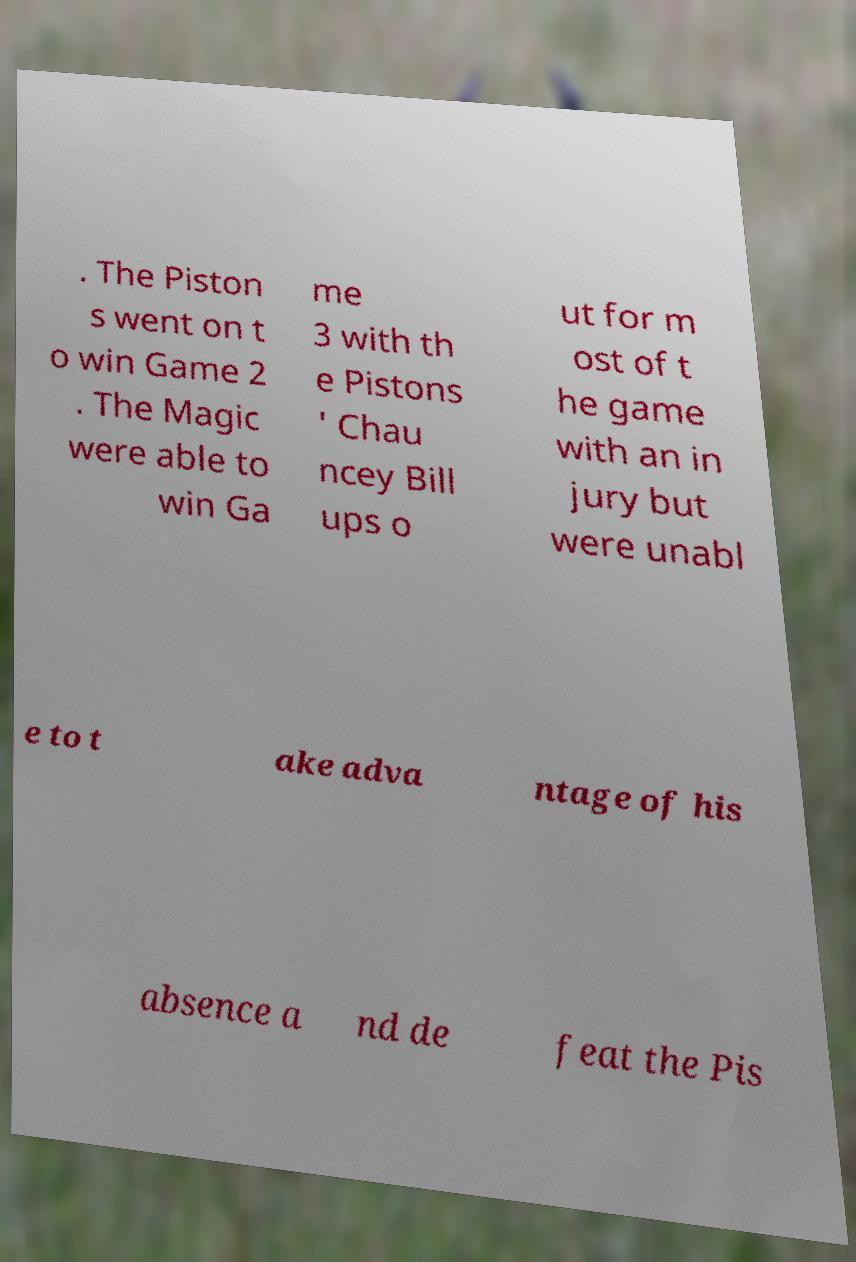I need the written content from this picture converted into text. Can you do that? . The Piston s went on t o win Game 2 . The Magic were able to win Ga me 3 with th e Pistons ' Chau ncey Bill ups o ut for m ost of t he game with an in jury but were unabl e to t ake adva ntage of his absence a nd de feat the Pis 